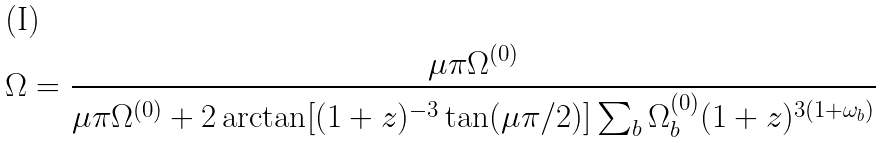Convert formula to latex. <formula><loc_0><loc_0><loc_500><loc_500>\Omega = \frac { \mu \pi \Omega ^ { ( 0 ) } } { \mu \pi \Omega ^ { ( 0 ) } + 2 \arctan [ ( 1 + z ) ^ { - 3 } \tan ( { \mu \pi } / 2 ) ] \sum _ { b } \Omega _ { b } ^ { ( 0 ) } ( 1 + z ) ^ { 3 ( 1 + \omega _ { b } ) } }</formula> 